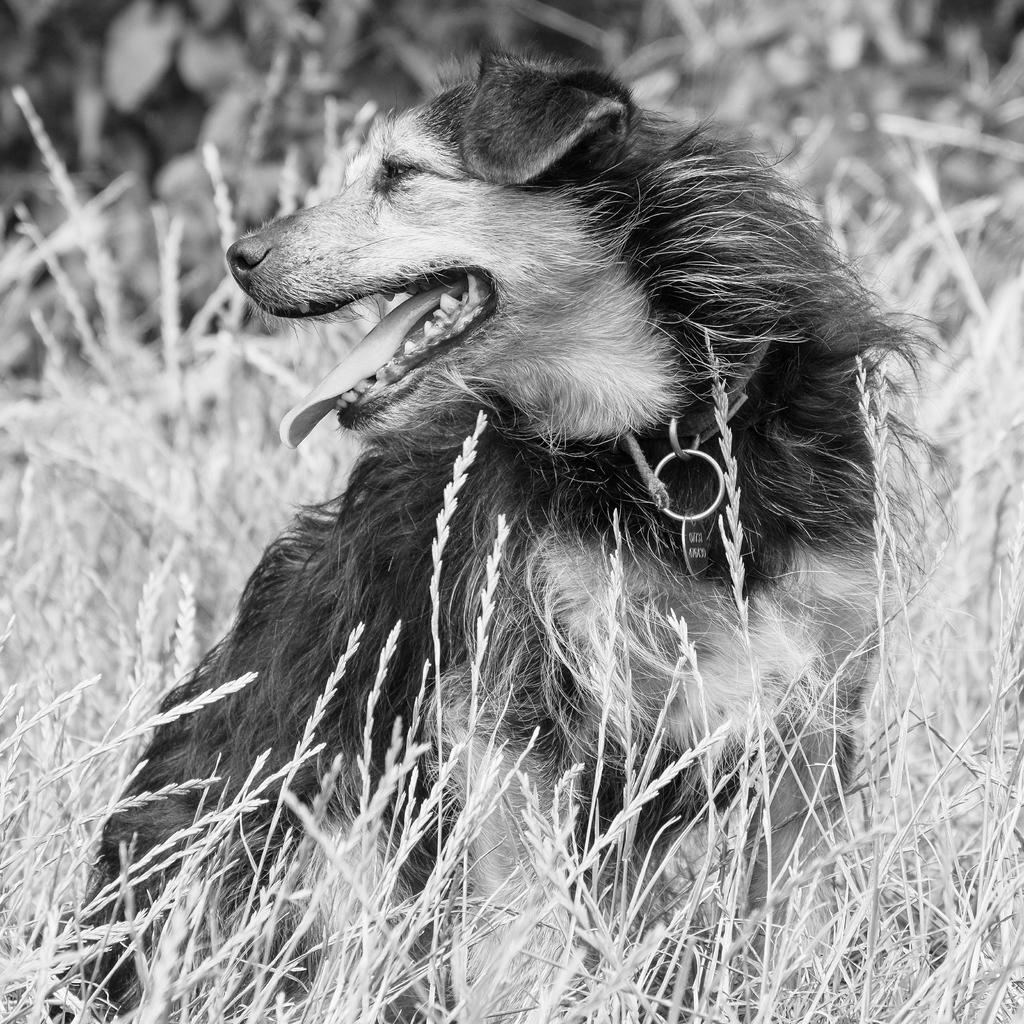What animal is present in the image? There is a dog in the picture. Where is the dog located in the image? The dog is sitting in the grass. What is the dog wearing around its neck? The dog has a belt around its neck. What is attached to the dog's belt? There is a locket on the dog's belt. In which direction is the dog looking? The dog is looking to the right. How would you describe the overall lighting or color of the image? The backdrop of the image is dark. What type of advice does the dog give to the person in the image? There is no person present in the image, and the dog does not give any advice. What color is the collar on the dog in the image? There is no collar present on the dog in the image; it has a belt around its neck. 